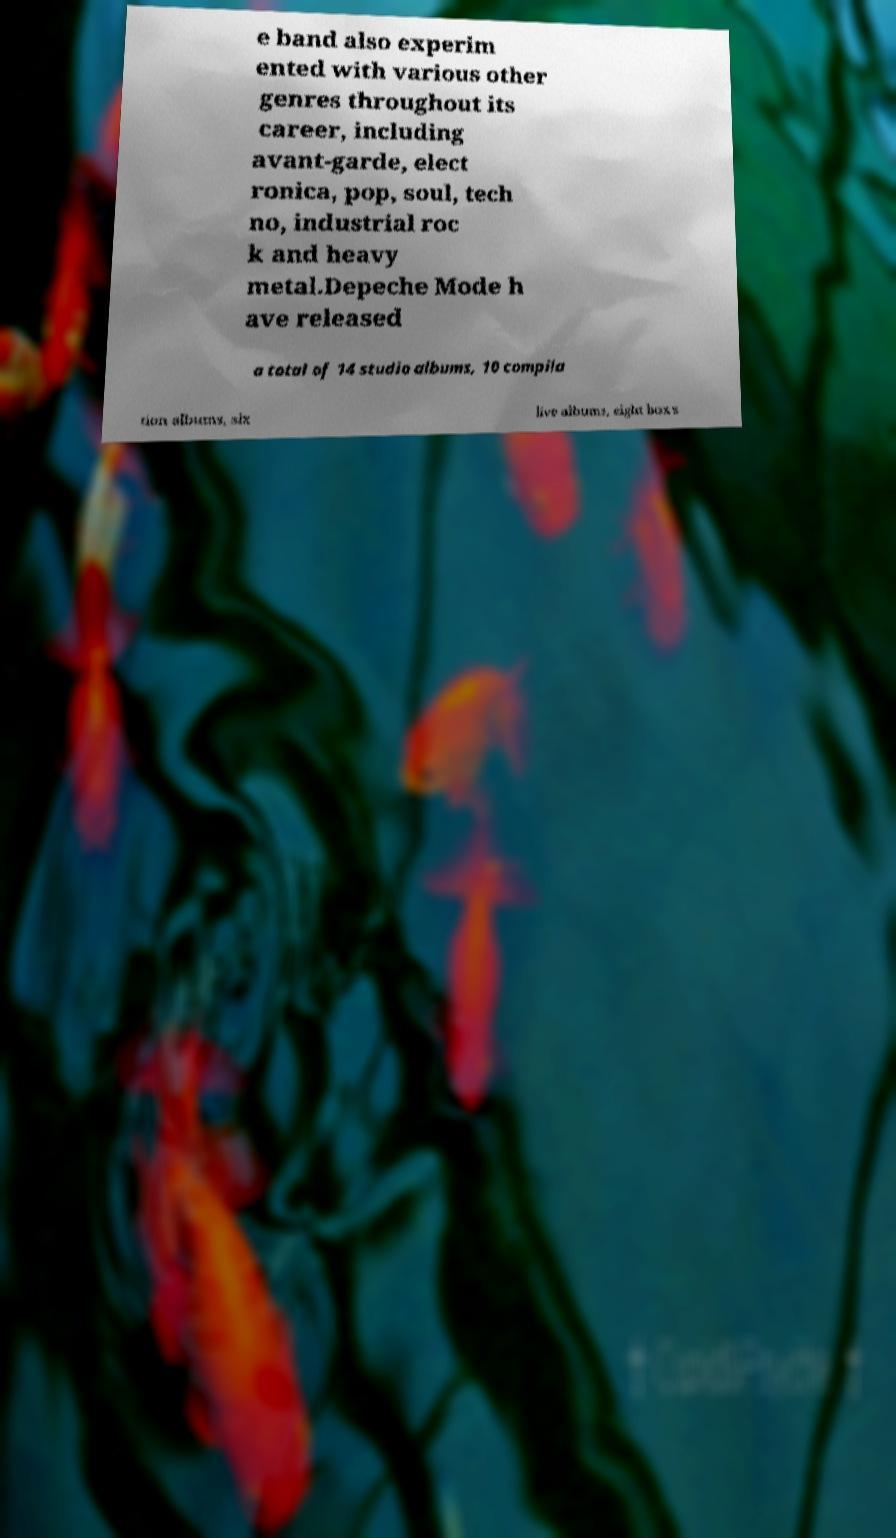There's text embedded in this image that I need extracted. Can you transcribe it verbatim? e band also experim ented with various other genres throughout its career, including avant-garde, elect ronica, pop, soul, tech no, industrial roc k and heavy metal.Depeche Mode h ave released a total of 14 studio albums, 10 compila tion albums, six live albums, eight box s 